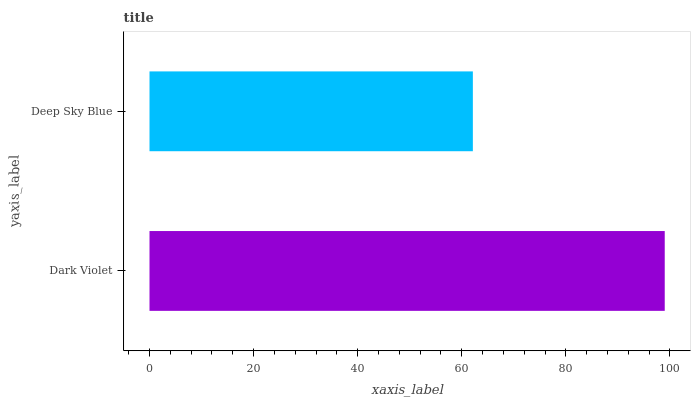Is Deep Sky Blue the minimum?
Answer yes or no. Yes. Is Dark Violet the maximum?
Answer yes or no. Yes. Is Deep Sky Blue the maximum?
Answer yes or no. No. Is Dark Violet greater than Deep Sky Blue?
Answer yes or no. Yes. Is Deep Sky Blue less than Dark Violet?
Answer yes or no. Yes. Is Deep Sky Blue greater than Dark Violet?
Answer yes or no. No. Is Dark Violet less than Deep Sky Blue?
Answer yes or no. No. Is Dark Violet the high median?
Answer yes or no. Yes. Is Deep Sky Blue the low median?
Answer yes or no. Yes. Is Deep Sky Blue the high median?
Answer yes or no. No. Is Dark Violet the low median?
Answer yes or no. No. 